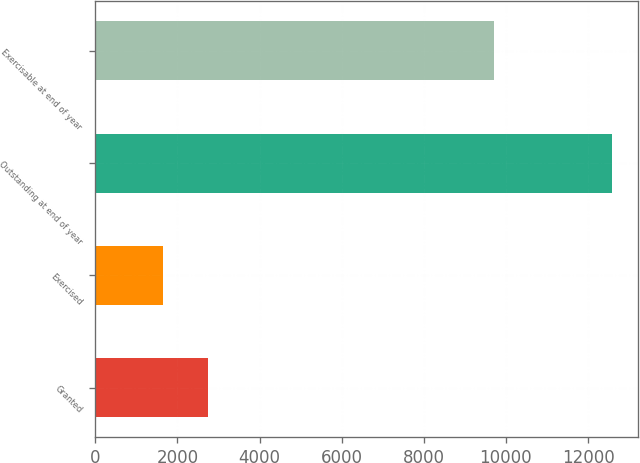<chart> <loc_0><loc_0><loc_500><loc_500><bar_chart><fcel>Granted<fcel>Exercised<fcel>Outstanding at end of year<fcel>Exercisable at end of year<nl><fcel>2742.8<fcel>1650<fcel>12578<fcel>9702<nl></chart> 